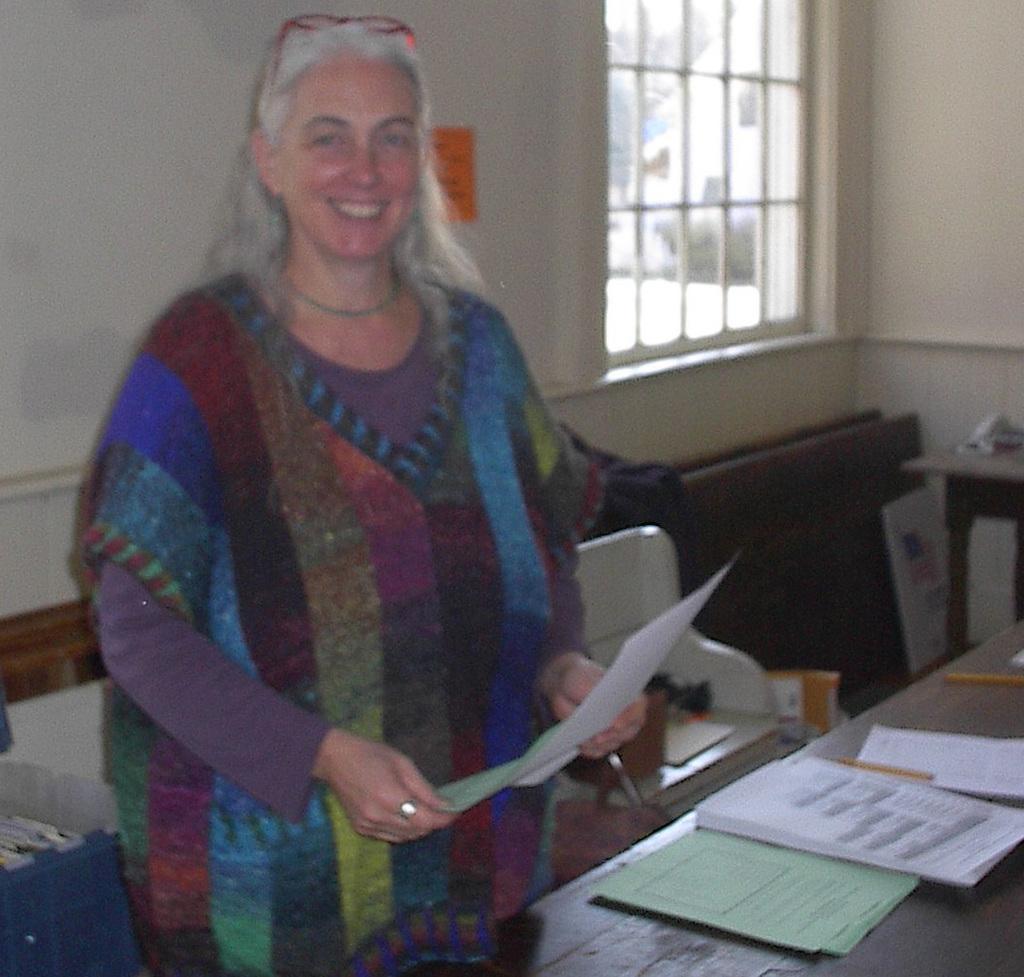Could you give a brief overview of what you see in this image? In this picture we can see a woman who is standing on the floor. And this is table. On the table there are some papers. On the background there is a wall and this is the window. 